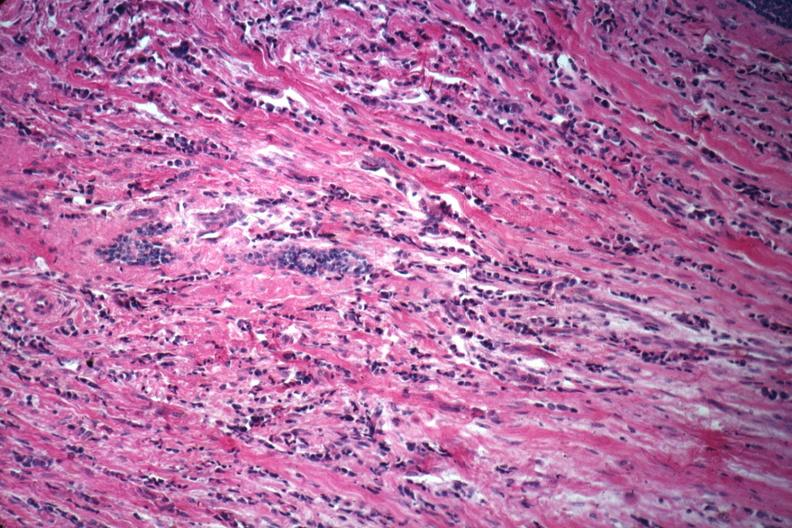what does this image show?
Answer the question using a single word or phrase. Good example of poorly differentiated infiltrating ductal carcinoma 